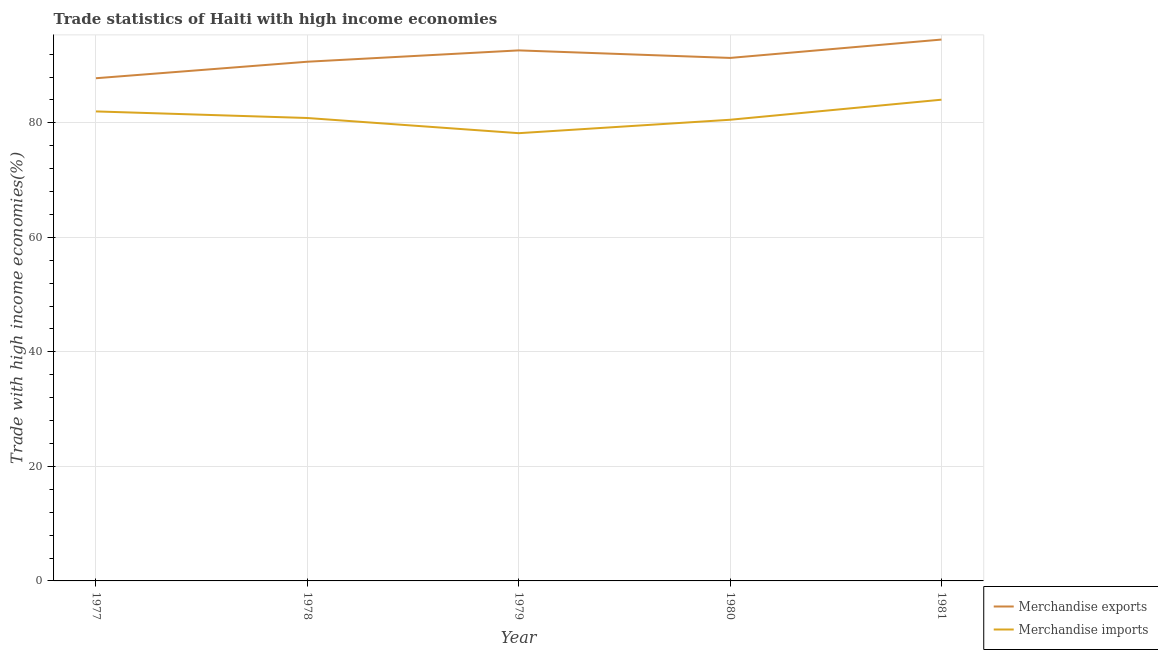Is the number of lines equal to the number of legend labels?
Your response must be concise. Yes. What is the merchandise exports in 1980?
Provide a short and direct response. 91.34. Across all years, what is the maximum merchandise exports?
Provide a succinct answer. 94.55. Across all years, what is the minimum merchandise imports?
Your answer should be compact. 78.2. In which year was the merchandise exports maximum?
Ensure brevity in your answer.  1981. What is the total merchandise exports in the graph?
Give a very brief answer. 457.04. What is the difference between the merchandise exports in 1978 and that in 1981?
Ensure brevity in your answer.  -3.87. What is the difference between the merchandise exports in 1980 and the merchandise imports in 1978?
Ensure brevity in your answer.  10.49. What is the average merchandise exports per year?
Offer a very short reply. 91.41. In the year 1977, what is the difference between the merchandise imports and merchandise exports?
Provide a succinct answer. -5.8. What is the ratio of the merchandise exports in 1979 to that in 1980?
Keep it short and to the point. 1.01. Is the difference between the merchandise exports in 1979 and 1980 greater than the difference between the merchandise imports in 1979 and 1980?
Your answer should be very brief. Yes. What is the difference between the highest and the second highest merchandise imports?
Give a very brief answer. 2.05. What is the difference between the highest and the lowest merchandise imports?
Offer a terse response. 5.85. Is the sum of the merchandise imports in 1977 and 1978 greater than the maximum merchandise exports across all years?
Offer a very short reply. Yes. How many lines are there?
Provide a short and direct response. 2. What is the difference between two consecutive major ticks on the Y-axis?
Your response must be concise. 20. Are the values on the major ticks of Y-axis written in scientific E-notation?
Provide a short and direct response. No. What is the title of the graph?
Provide a succinct answer. Trade statistics of Haiti with high income economies. Does "Male population" appear as one of the legend labels in the graph?
Offer a very short reply. No. What is the label or title of the X-axis?
Offer a very short reply. Year. What is the label or title of the Y-axis?
Give a very brief answer. Trade with high income economies(%). What is the Trade with high income economies(%) in Merchandise exports in 1977?
Keep it short and to the point. 87.8. What is the Trade with high income economies(%) in Merchandise imports in 1977?
Your response must be concise. 82. What is the Trade with high income economies(%) of Merchandise exports in 1978?
Your response must be concise. 90.68. What is the Trade with high income economies(%) in Merchandise imports in 1978?
Provide a short and direct response. 80.85. What is the Trade with high income economies(%) of Merchandise exports in 1979?
Your answer should be very brief. 92.66. What is the Trade with high income economies(%) of Merchandise imports in 1979?
Provide a succinct answer. 78.2. What is the Trade with high income economies(%) of Merchandise exports in 1980?
Provide a short and direct response. 91.34. What is the Trade with high income economies(%) in Merchandise imports in 1980?
Provide a succinct answer. 80.54. What is the Trade with high income economies(%) of Merchandise exports in 1981?
Provide a short and direct response. 94.55. What is the Trade with high income economies(%) of Merchandise imports in 1981?
Your response must be concise. 84.05. Across all years, what is the maximum Trade with high income economies(%) in Merchandise exports?
Give a very brief answer. 94.55. Across all years, what is the maximum Trade with high income economies(%) in Merchandise imports?
Make the answer very short. 84.05. Across all years, what is the minimum Trade with high income economies(%) in Merchandise exports?
Keep it short and to the point. 87.8. Across all years, what is the minimum Trade with high income economies(%) in Merchandise imports?
Offer a terse response. 78.2. What is the total Trade with high income economies(%) in Merchandise exports in the graph?
Your answer should be very brief. 457.04. What is the total Trade with high income economies(%) in Merchandise imports in the graph?
Offer a terse response. 405.65. What is the difference between the Trade with high income economies(%) in Merchandise exports in 1977 and that in 1978?
Your answer should be very brief. -2.88. What is the difference between the Trade with high income economies(%) in Merchandise imports in 1977 and that in 1978?
Provide a succinct answer. 1.15. What is the difference between the Trade with high income economies(%) in Merchandise exports in 1977 and that in 1979?
Your response must be concise. -4.86. What is the difference between the Trade with high income economies(%) in Merchandise imports in 1977 and that in 1979?
Your response must be concise. 3.8. What is the difference between the Trade with high income economies(%) of Merchandise exports in 1977 and that in 1980?
Give a very brief answer. -3.54. What is the difference between the Trade with high income economies(%) in Merchandise imports in 1977 and that in 1980?
Provide a succinct answer. 1.46. What is the difference between the Trade with high income economies(%) of Merchandise exports in 1977 and that in 1981?
Give a very brief answer. -6.75. What is the difference between the Trade with high income economies(%) in Merchandise imports in 1977 and that in 1981?
Make the answer very short. -2.05. What is the difference between the Trade with high income economies(%) of Merchandise exports in 1978 and that in 1979?
Make the answer very short. -1.98. What is the difference between the Trade with high income economies(%) in Merchandise imports in 1978 and that in 1979?
Make the answer very short. 2.65. What is the difference between the Trade with high income economies(%) in Merchandise exports in 1978 and that in 1980?
Your response must be concise. -0.66. What is the difference between the Trade with high income economies(%) of Merchandise imports in 1978 and that in 1980?
Give a very brief answer. 0.31. What is the difference between the Trade with high income economies(%) of Merchandise exports in 1978 and that in 1981?
Your answer should be compact. -3.87. What is the difference between the Trade with high income economies(%) in Merchandise imports in 1978 and that in 1981?
Provide a succinct answer. -3.2. What is the difference between the Trade with high income economies(%) in Merchandise exports in 1979 and that in 1980?
Make the answer very short. 1.32. What is the difference between the Trade with high income economies(%) in Merchandise imports in 1979 and that in 1980?
Offer a terse response. -2.34. What is the difference between the Trade with high income economies(%) of Merchandise exports in 1979 and that in 1981?
Provide a succinct answer. -1.89. What is the difference between the Trade with high income economies(%) in Merchandise imports in 1979 and that in 1981?
Your answer should be compact. -5.85. What is the difference between the Trade with high income economies(%) in Merchandise exports in 1980 and that in 1981?
Make the answer very short. -3.21. What is the difference between the Trade with high income economies(%) of Merchandise imports in 1980 and that in 1981?
Your answer should be compact. -3.5. What is the difference between the Trade with high income economies(%) in Merchandise exports in 1977 and the Trade with high income economies(%) in Merchandise imports in 1978?
Provide a short and direct response. 6.95. What is the difference between the Trade with high income economies(%) in Merchandise exports in 1977 and the Trade with high income economies(%) in Merchandise imports in 1979?
Your answer should be compact. 9.6. What is the difference between the Trade with high income economies(%) of Merchandise exports in 1977 and the Trade with high income economies(%) of Merchandise imports in 1980?
Provide a short and direct response. 7.25. What is the difference between the Trade with high income economies(%) of Merchandise exports in 1977 and the Trade with high income economies(%) of Merchandise imports in 1981?
Offer a very short reply. 3.75. What is the difference between the Trade with high income economies(%) of Merchandise exports in 1978 and the Trade with high income economies(%) of Merchandise imports in 1979?
Keep it short and to the point. 12.48. What is the difference between the Trade with high income economies(%) in Merchandise exports in 1978 and the Trade with high income economies(%) in Merchandise imports in 1980?
Make the answer very short. 10.14. What is the difference between the Trade with high income economies(%) in Merchandise exports in 1978 and the Trade with high income economies(%) in Merchandise imports in 1981?
Provide a short and direct response. 6.63. What is the difference between the Trade with high income economies(%) of Merchandise exports in 1979 and the Trade with high income economies(%) of Merchandise imports in 1980?
Your answer should be compact. 12.12. What is the difference between the Trade with high income economies(%) in Merchandise exports in 1979 and the Trade with high income economies(%) in Merchandise imports in 1981?
Provide a short and direct response. 8.61. What is the difference between the Trade with high income economies(%) of Merchandise exports in 1980 and the Trade with high income economies(%) of Merchandise imports in 1981?
Keep it short and to the point. 7.3. What is the average Trade with high income economies(%) of Merchandise exports per year?
Offer a terse response. 91.41. What is the average Trade with high income economies(%) of Merchandise imports per year?
Ensure brevity in your answer.  81.13. In the year 1977, what is the difference between the Trade with high income economies(%) in Merchandise exports and Trade with high income economies(%) in Merchandise imports?
Offer a very short reply. 5.8. In the year 1978, what is the difference between the Trade with high income economies(%) in Merchandise exports and Trade with high income economies(%) in Merchandise imports?
Keep it short and to the point. 9.83. In the year 1979, what is the difference between the Trade with high income economies(%) of Merchandise exports and Trade with high income economies(%) of Merchandise imports?
Give a very brief answer. 14.46. In the year 1980, what is the difference between the Trade with high income economies(%) of Merchandise exports and Trade with high income economies(%) of Merchandise imports?
Ensure brevity in your answer.  10.8. In the year 1981, what is the difference between the Trade with high income economies(%) in Merchandise exports and Trade with high income economies(%) in Merchandise imports?
Provide a succinct answer. 10.5. What is the ratio of the Trade with high income economies(%) of Merchandise exports in 1977 to that in 1978?
Offer a very short reply. 0.97. What is the ratio of the Trade with high income economies(%) in Merchandise imports in 1977 to that in 1978?
Keep it short and to the point. 1.01. What is the ratio of the Trade with high income economies(%) in Merchandise exports in 1977 to that in 1979?
Make the answer very short. 0.95. What is the ratio of the Trade with high income economies(%) in Merchandise imports in 1977 to that in 1979?
Make the answer very short. 1.05. What is the ratio of the Trade with high income economies(%) in Merchandise exports in 1977 to that in 1980?
Give a very brief answer. 0.96. What is the ratio of the Trade with high income economies(%) in Merchandise imports in 1977 to that in 1980?
Your answer should be very brief. 1.02. What is the ratio of the Trade with high income economies(%) in Merchandise imports in 1977 to that in 1981?
Provide a succinct answer. 0.98. What is the ratio of the Trade with high income economies(%) of Merchandise exports in 1978 to that in 1979?
Offer a terse response. 0.98. What is the ratio of the Trade with high income economies(%) in Merchandise imports in 1978 to that in 1979?
Ensure brevity in your answer.  1.03. What is the ratio of the Trade with high income economies(%) of Merchandise exports in 1978 to that in 1980?
Provide a short and direct response. 0.99. What is the ratio of the Trade with high income economies(%) of Merchandise imports in 1978 to that in 1980?
Your answer should be compact. 1. What is the ratio of the Trade with high income economies(%) of Merchandise imports in 1978 to that in 1981?
Your answer should be compact. 0.96. What is the ratio of the Trade with high income economies(%) in Merchandise exports in 1979 to that in 1980?
Offer a very short reply. 1.01. What is the ratio of the Trade with high income economies(%) in Merchandise imports in 1979 to that in 1980?
Provide a succinct answer. 0.97. What is the ratio of the Trade with high income economies(%) of Merchandise imports in 1979 to that in 1981?
Provide a short and direct response. 0.93. What is the ratio of the Trade with high income economies(%) of Merchandise exports in 1980 to that in 1981?
Make the answer very short. 0.97. What is the difference between the highest and the second highest Trade with high income economies(%) in Merchandise exports?
Provide a succinct answer. 1.89. What is the difference between the highest and the second highest Trade with high income economies(%) of Merchandise imports?
Keep it short and to the point. 2.05. What is the difference between the highest and the lowest Trade with high income economies(%) of Merchandise exports?
Your response must be concise. 6.75. What is the difference between the highest and the lowest Trade with high income economies(%) in Merchandise imports?
Provide a short and direct response. 5.85. 